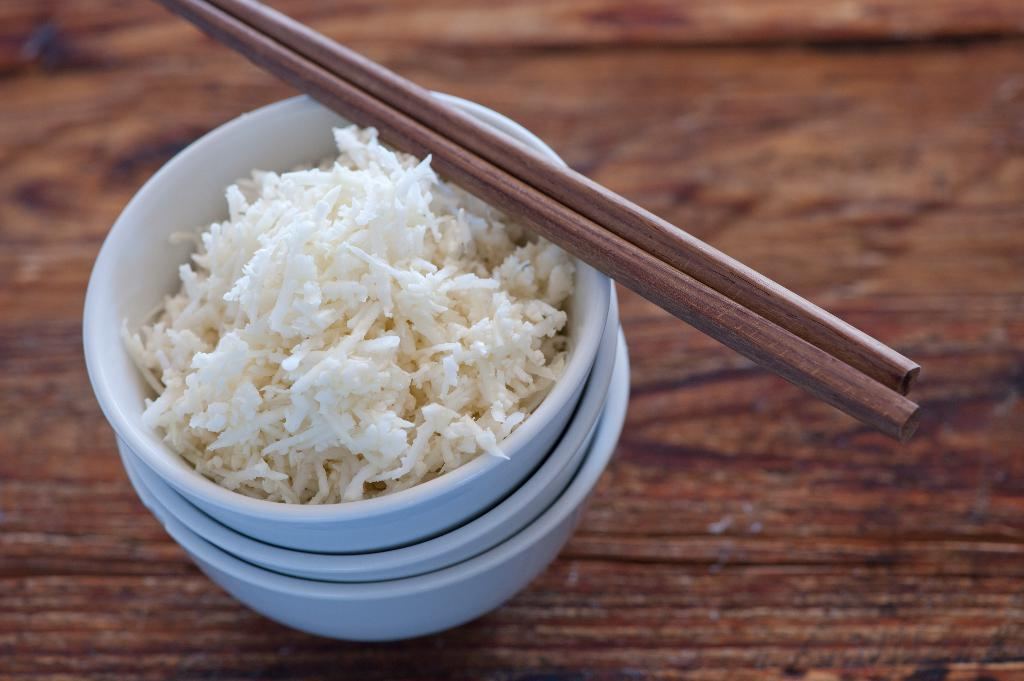How many bowls are visible in the image? There are three blue color bowls in the image. What is inside the bowls? The bowls contain rice. What type of utensils are present in the image? There are wooden chopsticks in the image. Where are the wooden chopsticks placed? The wooden chopsticks are placed on a wooden table. What type of playground equipment can be seen in the image? There is no playground equipment present in the image; it features three blue color bowls containing rice, wooden chopsticks, and a wooden table. 